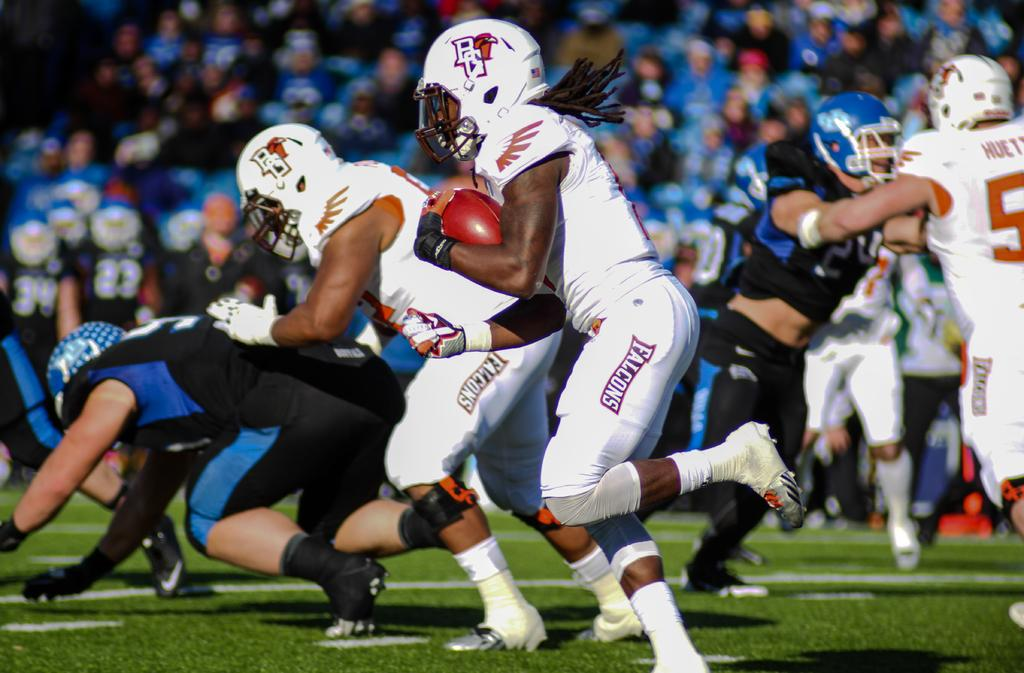What is happening in the image? There is a group of people in the image, and they appear to be playing baseball. Can you describe the activity the people are engaged in? The people are playing baseball, which involves hitting a ball with a bat and running around bases. What type of boats can be seen in the image? There are no boats present in the image; it features a group of people playing baseball. How many fans are visible in the image? There is no mention of fans in the image; it only shows a group of people playing baseball. 